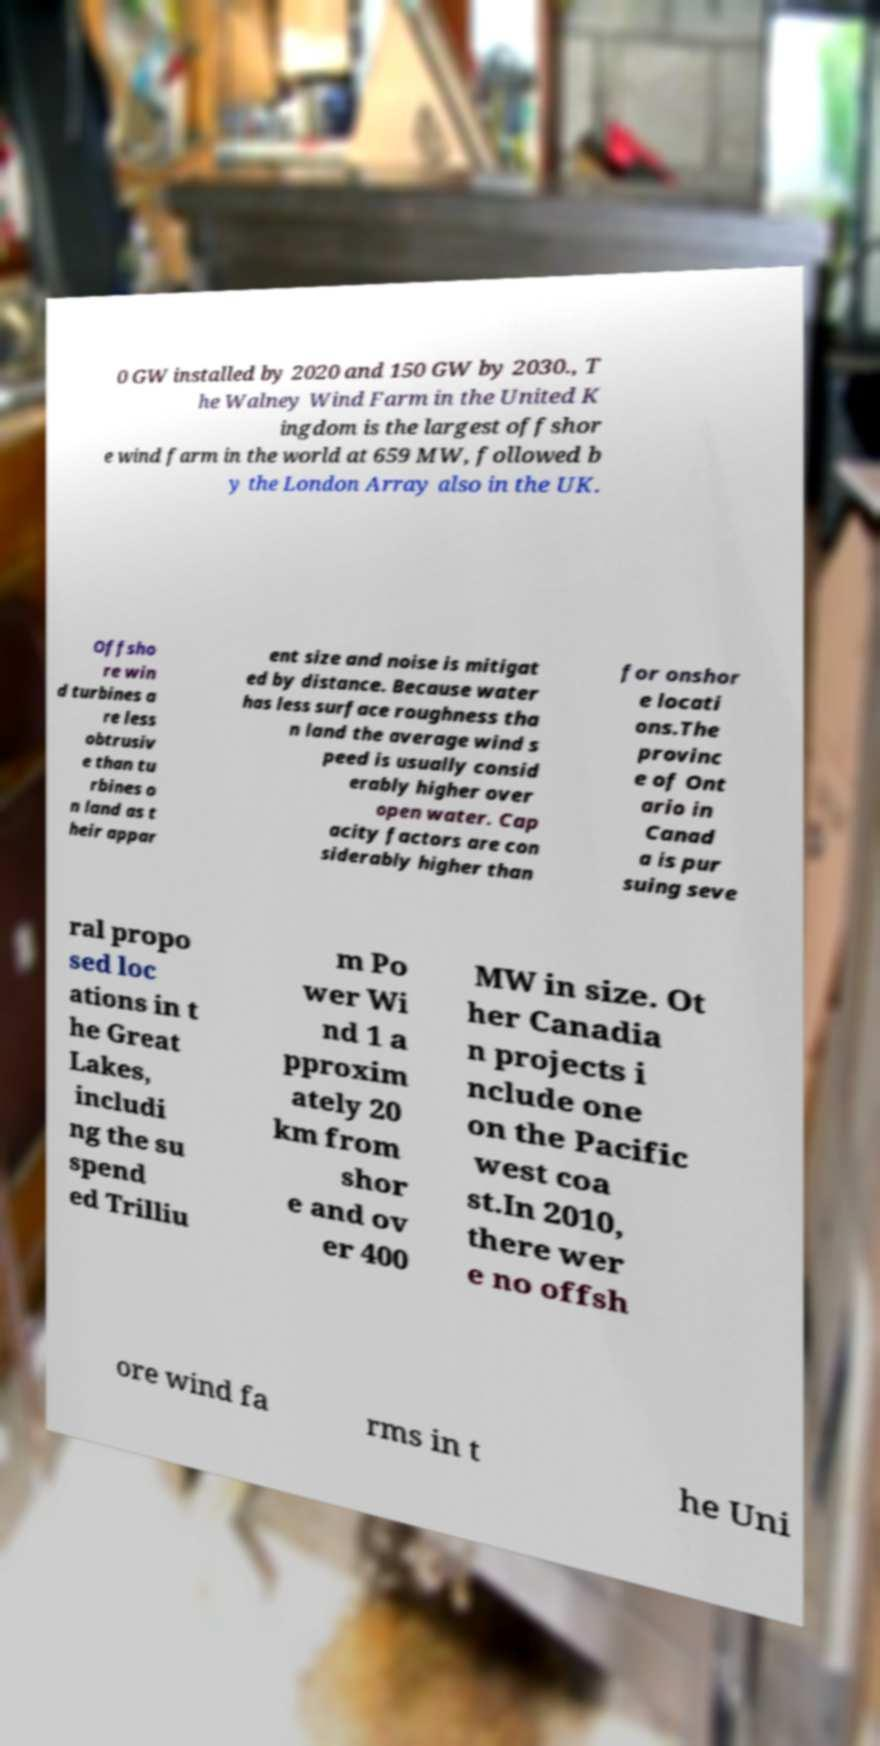There's text embedded in this image that I need extracted. Can you transcribe it verbatim? 0 GW installed by 2020 and 150 GW by 2030., T he Walney Wind Farm in the United K ingdom is the largest offshor e wind farm in the world at 659 MW, followed b y the London Array also in the UK. Offsho re win d turbines a re less obtrusiv e than tu rbines o n land as t heir appar ent size and noise is mitigat ed by distance. Because water has less surface roughness tha n land the average wind s peed is usually consid erably higher over open water. Cap acity factors are con siderably higher than for onshor e locati ons.The provinc e of Ont ario in Canad a is pur suing seve ral propo sed loc ations in t he Great Lakes, includi ng the su spend ed Trilliu m Po wer Wi nd 1 a pproxim ately 20 km from shor e and ov er 400 MW in size. Ot her Canadia n projects i nclude one on the Pacific west coa st.In 2010, there wer e no offsh ore wind fa rms in t he Uni 